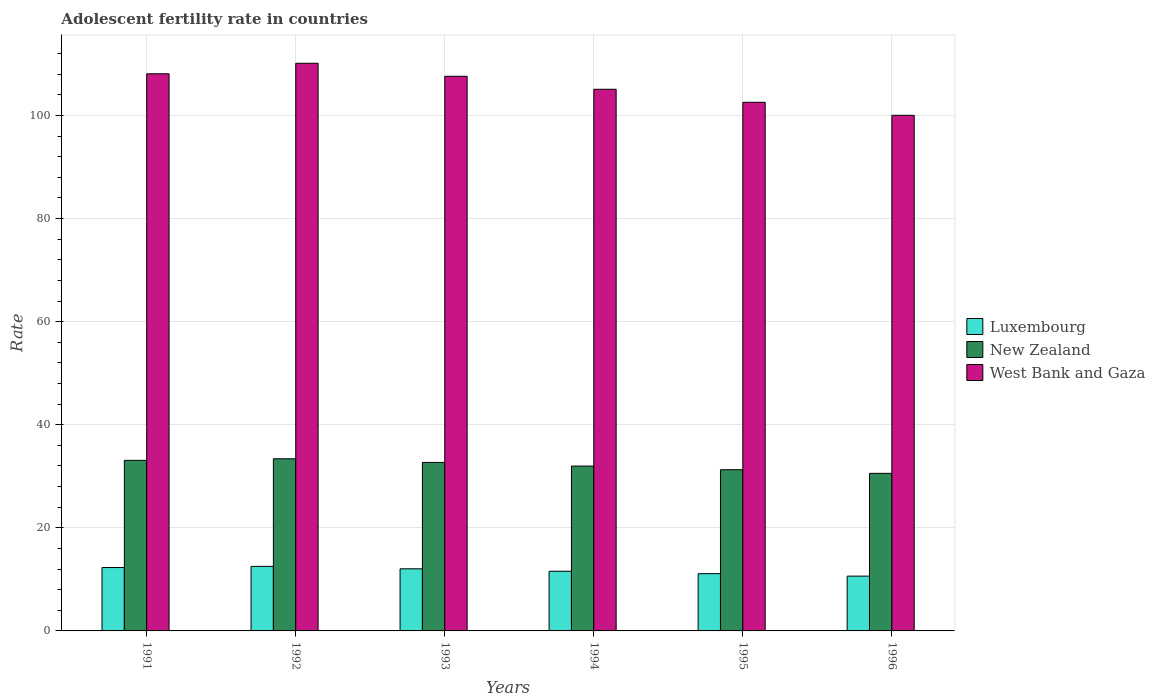How many different coloured bars are there?
Provide a short and direct response. 3. How many bars are there on the 6th tick from the left?
Keep it short and to the point. 3. What is the label of the 3rd group of bars from the left?
Offer a terse response. 1993. In how many cases, is the number of bars for a given year not equal to the number of legend labels?
Keep it short and to the point. 0. What is the adolescent fertility rate in New Zealand in 1991?
Keep it short and to the point. 33.09. Across all years, what is the maximum adolescent fertility rate in New Zealand?
Ensure brevity in your answer.  33.4. Across all years, what is the minimum adolescent fertility rate in New Zealand?
Offer a terse response. 30.57. In which year was the adolescent fertility rate in West Bank and Gaza maximum?
Your response must be concise. 1992. In which year was the adolescent fertility rate in New Zealand minimum?
Make the answer very short. 1996. What is the total adolescent fertility rate in Luxembourg in the graph?
Your answer should be compact. 70.18. What is the difference between the adolescent fertility rate in Luxembourg in 1992 and that in 1993?
Your answer should be very brief. 0.47. What is the difference between the adolescent fertility rate in West Bank and Gaza in 1992 and the adolescent fertility rate in Luxembourg in 1994?
Keep it short and to the point. 98.55. What is the average adolescent fertility rate in New Zealand per year?
Provide a succinct answer. 32.17. In the year 1992, what is the difference between the adolescent fertility rate in Luxembourg and adolescent fertility rate in New Zealand?
Your answer should be compact. -20.88. In how many years, is the adolescent fertility rate in West Bank and Gaza greater than 48?
Provide a short and direct response. 6. What is the ratio of the adolescent fertility rate in West Bank and Gaza in 1991 to that in 1993?
Offer a terse response. 1. Is the adolescent fertility rate in New Zealand in 1992 less than that in 1993?
Give a very brief answer. No. What is the difference between the highest and the second highest adolescent fertility rate in New Zealand?
Your answer should be very brief. 0.31. What is the difference between the highest and the lowest adolescent fertility rate in West Bank and Gaza?
Your answer should be very brief. 10.1. What does the 2nd bar from the left in 1993 represents?
Give a very brief answer. New Zealand. What does the 1st bar from the right in 1994 represents?
Offer a very short reply. West Bank and Gaza. Is it the case that in every year, the sum of the adolescent fertility rate in West Bank and Gaza and adolescent fertility rate in Luxembourg is greater than the adolescent fertility rate in New Zealand?
Offer a very short reply. Yes. How many bars are there?
Make the answer very short. 18. Are all the bars in the graph horizontal?
Keep it short and to the point. No. How many years are there in the graph?
Provide a succinct answer. 6. What is the difference between two consecutive major ticks on the Y-axis?
Provide a succinct answer. 20. Are the values on the major ticks of Y-axis written in scientific E-notation?
Provide a succinct answer. No. Where does the legend appear in the graph?
Ensure brevity in your answer.  Center right. What is the title of the graph?
Offer a terse response. Adolescent fertility rate in countries. Does "Congo (Republic)" appear as one of the legend labels in the graph?
Your answer should be compact. No. What is the label or title of the X-axis?
Offer a very short reply. Years. What is the label or title of the Y-axis?
Provide a short and direct response. Rate. What is the Rate in Luxembourg in 1991?
Your answer should be compact. 12.3. What is the Rate in New Zealand in 1991?
Give a very brief answer. 33.09. What is the Rate of West Bank and Gaza in 1991?
Your answer should be compact. 108.08. What is the Rate of Luxembourg in 1992?
Offer a very short reply. 12.52. What is the Rate of New Zealand in 1992?
Give a very brief answer. 33.4. What is the Rate of West Bank and Gaza in 1992?
Provide a succinct answer. 110.13. What is the Rate of Luxembourg in 1993?
Keep it short and to the point. 12.05. What is the Rate in New Zealand in 1993?
Your answer should be very brief. 32.69. What is the Rate of West Bank and Gaza in 1993?
Your answer should be very brief. 107.6. What is the Rate in Luxembourg in 1994?
Provide a short and direct response. 11.58. What is the Rate in New Zealand in 1994?
Offer a terse response. 31.98. What is the Rate of West Bank and Gaza in 1994?
Your response must be concise. 105.08. What is the Rate of Luxembourg in 1995?
Provide a short and direct response. 11.1. What is the Rate in New Zealand in 1995?
Ensure brevity in your answer.  31.28. What is the Rate of West Bank and Gaza in 1995?
Offer a terse response. 102.55. What is the Rate of Luxembourg in 1996?
Make the answer very short. 10.63. What is the Rate in New Zealand in 1996?
Make the answer very short. 30.57. What is the Rate in West Bank and Gaza in 1996?
Give a very brief answer. 100.03. Across all years, what is the maximum Rate in Luxembourg?
Your response must be concise. 12.52. Across all years, what is the maximum Rate of New Zealand?
Provide a short and direct response. 33.4. Across all years, what is the maximum Rate of West Bank and Gaza?
Your answer should be compact. 110.13. Across all years, what is the minimum Rate of Luxembourg?
Provide a short and direct response. 10.63. Across all years, what is the minimum Rate of New Zealand?
Provide a succinct answer. 30.57. Across all years, what is the minimum Rate in West Bank and Gaza?
Your answer should be compact. 100.03. What is the total Rate in Luxembourg in the graph?
Offer a terse response. 70.18. What is the total Rate in New Zealand in the graph?
Keep it short and to the point. 193.01. What is the total Rate in West Bank and Gaza in the graph?
Give a very brief answer. 633.48. What is the difference between the Rate in Luxembourg in 1991 and that in 1992?
Provide a succinct answer. -0.22. What is the difference between the Rate of New Zealand in 1991 and that in 1992?
Keep it short and to the point. -0.31. What is the difference between the Rate of West Bank and Gaza in 1991 and that in 1992?
Ensure brevity in your answer.  -2.04. What is the difference between the Rate in Luxembourg in 1991 and that in 1993?
Keep it short and to the point. 0.25. What is the difference between the Rate in New Zealand in 1991 and that in 1993?
Your answer should be very brief. 0.4. What is the difference between the Rate of West Bank and Gaza in 1991 and that in 1993?
Provide a succinct answer. 0.48. What is the difference between the Rate of Luxembourg in 1991 and that in 1994?
Keep it short and to the point. 0.72. What is the difference between the Rate in New Zealand in 1991 and that in 1994?
Your answer should be very brief. 1.11. What is the difference between the Rate of West Bank and Gaza in 1991 and that in 1994?
Offer a very short reply. 3. What is the difference between the Rate of Luxembourg in 1991 and that in 1995?
Ensure brevity in your answer.  1.19. What is the difference between the Rate in New Zealand in 1991 and that in 1995?
Make the answer very short. 1.81. What is the difference between the Rate in West Bank and Gaza in 1991 and that in 1995?
Provide a succinct answer. 5.53. What is the difference between the Rate in Luxembourg in 1991 and that in 1996?
Provide a succinct answer. 1.67. What is the difference between the Rate in New Zealand in 1991 and that in 1996?
Keep it short and to the point. 2.52. What is the difference between the Rate in West Bank and Gaza in 1991 and that in 1996?
Ensure brevity in your answer.  8.05. What is the difference between the Rate of Luxembourg in 1992 and that in 1993?
Provide a succinct answer. 0.47. What is the difference between the Rate of New Zealand in 1992 and that in 1993?
Provide a succinct answer. 0.71. What is the difference between the Rate of West Bank and Gaza in 1992 and that in 1993?
Offer a terse response. 2.52. What is the difference between the Rate in Luxembourg in 1992 and that in 1994?
Offer a terse response. 0.95. What is the difference between the Rate of New Zealand in 1992 and that in 1994?
Offer a very short reply. 1.41. What is the difference between the Rate of West Bank and Gaza in 1992 and that in 1994?
Your answer should be very brief. 5.05. What is the difference between the Rate of Luxembourg in 1992 and that in 1995?
Provide a short and direct response. 1.42. What is the difference between the Rate in New Zealand in 1992 and that in 1995?
Offer a very short reply. 2.12. What is the difference between the Rate in West Bank and Gaza in 1992 and that in 1995?
Your response must be concise. 7.57. What is the difference between the Rate of Luxembourg in 1992 and that in 1996?
Give a very brief answer. 1.89. What is the difference between the Rate in New Zealand in 1992 and that in 1996?
Provide a short and direct response. 2.83. What is the difference between the Rate of West Bank and Gaza in 1992 and that in 1996?
Your response must be concise. 10.1. What is the difference between the Rate in Luxembourg in 1993 and that in 1994?
Keep it short and to the point. 0.47. What is the difference between the Rate of New Zealand in 1993 and that in 1994?
Make the answer very short. 0.71. What is the difference between the Rate of West Bank and Gaza in 1993 and that in 1994?
Provide a short and direct response. 2.52. What is the difference between the Rate in Luxembourg in 1993 and that in 1995?
Provide a succinct answer. 0.95. What is the difference between the Rate of New Zealand in 1993 and that in 1995?
Your answer should be compact. 1.41. What is the difference between the Rate in West Bank and Gaza in 1993 and that in 1995?
Make the answer very short. 5.05. What is the difference between the Rate in Luxembourg in 1993 and that in 1996?
Your response must be concise. 1.42. What is the difference between the Rate in New Zealand in 1993 and that in 1996?
Provide a succinct answer. 2.12. What is the difference between the Rate in West Bank and Gaza in 1993 and that in 1996?
Provide a succinct answer. 7.57. What is the difference between the Rate of Luxembourg in 1994 and that in 1995?
Offer a terse response. 0.47. What is the difference between the Rate in New Zealand in 1994 and that in 1995?
Your answer should be compact. 0.71. What is the difference between the Rate in West Bank and Gaza in 1994 and that in 1995?
Provide a succinct answer. 2.52. What is the difference between the Rate of Luxembourg in 1994 and that in 1996?
Provide a succinct answer. 0.95. What is the difference between the Rate of New Zealand in 1994 and that in 1996?
Give a very brief answer. 1.41. What is the difference between the Rate of West Bank and Gaza in 1994 and that in 1996?
Your response must be concise. 5.05. What is the difference between the Rate of Luxembourg in 1995 and that in 1996?
Offer a terse response. 0.47. What is the difference between the Rate in New Zealand in 1995 and that in 1996?
Keep it short and to the point. 0.71. What is the difference between the Rate in West Bank and Gaza in 1995 and that in 1996?
Your answer should be very brief. 2.52. What is the difference between the Rate in Luxembourg in 1991 and the Rate in New Zealand in 1992?
Your answer should be compact. -21.1. What is the difference between the Rate in Luxembourg in 1991 and the Rate in West Bank and Gaza in 1992?
Ensure brevity in your answer.  -97.83. What is the difference between the Rate of New Zealand in 1991 and the Rate of West Bank and Gaza in 1992?
Your response must be concise. -77.04. What is the difference between the Rate in Luxembourg in 1991 and the Rate in New Zealand in 1993?
Your response must be concise. -20.39. What is the difference between the Rate in Luxembourg in 1991 and the Rate in West Bank and Gaza in 1993?
Provide a short and direct response. -95.31. What is the difference between the Rate of New Zealand in 1991 and the Rate of West Bank and Gaza in 1993?
Provide a short and direct response. -74.51. What is the difference between the Rate in Luxembourg in 1991 and the Rate in New Zealand in 1994?
Keep it short and to the point. -19.69. What is the difference between the Rate in Luxembourg in 1991 and the Rate in West Bank and Gaza in 1994?
Offer a terse response. -92.78. What is the difference between the Rate in New Zealand in 1991 and the Rate in West Bank and Gaza in 1994?
Ensure brevity in your answer.  -71.99. What is the difference between the Rate in Luxembourg in 1991 and the Rate in New Zealand in 1995?
Provide a succinct answer. -18.98. What is the difference between the Rate in Luxembourg in 1991 and the Rate in West Bank and Gaza in 1995?
Ensure brevity in your answer.  -90.26. What is the difference between the Rate of New Zealand in 1991 and the Rate of West Bank and Gaza in 1995?
Provide a short and direct response. -69.46. What is the difference between the Rate in Luxembourg in 1991 and the Rate in New Zealand in 1996?
Provide a succinct answer. -18.27. What is the difference between the Rate in Luxembourg in 1991 and the Rate in West Bank and Gaza in 1996?
Offer a terse response. -87.73. What is the difference between the Rate of New Zealand in 1991 and the Rate of West Bank and Gaza in 1996?
Your answer should be very brief. -66.94. What is the difference between the Rate of Luxembourg in 1992 and the Rate of New Zealand in 1993?
Keep it short and to the point. -20.17. What is the difference between the Rate in Luxembourg in 1992 and the Rate in West Bank and Gaza in 1993?
Offer a very short reply. -95.08. What is the difference between the Rate of New Zealand in 1992 and the Rate of West Bank and Gaza in 1993?
Keep it short and to the point. -74.2. What is the difference between the Rate in Luxembourg in 1992 and the Rate in New Zealand in 1994?
Give a very brief answer. -19.46. What is the difference between the Rate in Luxembourg in 1992 and the Rate in West Bank and Gaza in 1994?
Provide a short and direct response. -92.56. What is the difference between the Rate in New Zealand in 1992 and the Rate in West Bank and Gaza in 1994?
Your answer should be very brief. -71.68. What is the difference between the Rate in Luxembourg in 1992 and the Rate in New Zealand in 1995?
Your response must be concise. -18.75. What is the difference between the Rate of Luxembourg in 1992 and the Rate of West Bank and Gaza in 1995?
Make the answer very short. -90.03. What is the difference between the Rate of New Zealand in 1992 and the Rate of West Bank and Gaza in 1995?
Ensure brevity in your answer.  -69.16. What is the difference between the Rate of Luxembourg in 1992 and the Rate of New Zealand in 1996?
Offer a very short reply. -18.05. What is the difference between the Rate in Luxembourg in 1992 and the Rate in West Bank and Gaza in 1996?
Offer a very short reply. -87.51. What is the difference between the Rate of New Zealand in 1992 and the Rate of West Bank and Gaza in 1996?
Offer a very short reply. -66.63. What is the difference between the Rate in Luxembourg in 1993 and the Rate in New Zealand in 1994?
Provide a short and direct response. -19.93. What is the difference between the Rate of Luxembourg in 1993 and the Rate of West Bank and Gaza in 1994?
Give a very brief answer. -93.03. What is the difference between the Rate in New Zealand in 1993 and the Rate in West Bank and Gaza in 1994?
Give a very brief answer. -72.39. What is the difference between the Rate in Luxembourg in 1993 and the Rate in New Zealand in 1995?
Keep it short and to the point. -19.23. What is the difference between the Rate of Luxembourg in 1993 and the Rate of West Bank and Gaza in 1995?
Ensure brevity in your answer.  -90.5. What is the difference between the Rate of New Zealand in 1993 and the Rate of West Bank and Gaza in 1995?
Your response must be concise. -69.86. What is the difference between the Rate of Luxembourg in 1993 and the Rate of New Zealand in 1996?
Ensure brevity in your answer.  -18.52. What is the difference between the Rate in Luxembourg in 1993 and the Rate in West Bank and Gaza in 1996?
Provide a short and direct response. -87.98. What is the difference between the Rate of New Zealand in 1993 and the Rate of West Bank and Gaza in 1996?
Keep it short and to the point. -67.34. What is the difference between the Rate of Luxembourg in 1994 and the Rate of New Zealand in 1995?
Keep it short and to the point. -19.7. What is the difference between the Rate of Luxembourg in 1994 and the Rate of West Bank and Gaza in 1995?
Offer a very short reply. -90.98. What is the difference between the Rate in New Zealand in 1994 and the Rate in West Bank and Gaza in 1995?
Your answer should be very brief. -70.57. What is the difference between the Rate in Luxembourg in 1994 and the Rate in New Zealand in 1996?
Ensure brevity in your answer.  -18.99. What is the difference between the Rate in Luxembourg in 1994 and the Rate in West Bank and Gaza in 1996?
Your answer should be very brief. -88.45. What is the difference between the Rate in New Zealand in 1994 and the Rate in West Bank and Gaza in 1996?
Your answer should be very brief. -68.05. What is the difference between the Rate of Luxembourg in 1995 and the Rate of New Zealand in 1996?
Provide a short and direct response. -19.46. What is the difference between the Rate in Luxembourg in 1995 and the Rate in West Bank and Gaza in 1996?
Offer a terse response. -88.93. What is the difference between the Rate in New Zealand in 1995 and the Rate in West Bank and Gaza in 1996?
Your response must be concise. -68.75. What is the average Rate in Luxembourg per year?
Give a very brief answer. 11.7. What is the average Rate of New Zealand per year?
Your answer should be compact. 32.17. What is the average Rate in West Bank and Gaza per year?
Offer a very short reply. 105.58. In the year 1991, what is the difference between the Rate of Luxembourg and Rate of New Zealand?
Your answer should be very brief. -20.79. In the year 1991, what is the difference between the Rate in Luxembourg and Rate in West Bank and Gaza?
Your answer should be compact. -95.79. In the year 1991, what is the difference between the Rate of New Zealand and Rate of West Bank and Gaza?
Provide a succinct answer. -74.99. In the year 1992, what is the difference between the Rate of Luxembourg and Rate of New Zealand?
Make the answer very short. -20.88. In the year 1992, what is the difference between the Rate in Luxembourg and Rate in West Bank and Gaza?
Your answer should be compact. -97.61. In the year 1992, what is the difference between the Rate of New Zealand and Rate of West Bank and Gaza?
Ensure brevity in your answer.  -76.73. In the year 1993, what is the difference between the Rate of Luxembourg and Rate of New Zealand?
Your answer should be compact. -20.64. In the year 1993, what is the difference between the Rate in Luxembourg and Rate in West Bank and Gaza?
Your answer should be very brief. -95.55. In the year 1993, what is the difference between the Rate of New Zealand and Rate of West Bank and Gaza?
Provide a short and direct response. -74.91. In the year 1994, what is the difference between the Rate in Luxembourg and Rate in New Zealand?
Provide a short and direct response. -20.41. In the year 1994, what is the difference between the Rate in Luxembourg and Rate in West Bank and Gaza?
Offer a terse response. -93.5. In the year 1994, what is the difference between the Rate of New Zealand and Rate of West Bank and Gaza?
Offer a terse response. -73.09. In the year 1995, what is the difference between the Rate of Luxembourg and Rate of New Zealand?
Your answer should be very brief. -20.17. In the year 1995, what is the difference between the Rate in Luxembourg and Rate in West Bank and Gaza?
Your answer should be compact. -91.45. In the year 1995, what is the difference between the Rate of New Zealand and Rate of West Bank and Gaza?
Give a very brief answer. -71.28. In the year 1996, what is the difference between the Rate of Luxembourg and Rate of New Zealand?
Offer a terse response. -19.94. In the year 1996, what is the difference between the Rate in Luxembourg and Rate in West Bank and Gaza?
Your response must be concise. -89.4. In the year 1996, what is the difference between the Rate in New Zealand and Rate in West Bank and Gaza?
Make the answer very short. -69.46. What is the ratio of the Rate of Luxembourg in 1991 to that in 1992?
Give a very brief answer. 0.98. What is the ratio of the Rate of West Bank and Gaza in 1991 to that in 1992?
Give a very brief answer. 0.98. What is the ratio of the Rate in Luxembourg in 1991 to that in 1993?
Ensure brevity in your answer.  1.02. What is the ratio of the Rate of New Zealand in 1991 to that in 1993?
Your answer should be compact. 1.01. What is the ratio of the Rate in Luxembourg in 1991 to that in 1994?
Ensure brevity in your answer.  1.06. What is the ratio of the Rate in New Zealand in 1991 to that in 1994?
Ensure brevity in your answer.  1.03. What is the ratio of the Rate of West Bank and Gaza in 1991 to that in 1994?
Offer a terse response. 1.03. What is the ratio of the Rate in Luxembourg in 1991 to that in 1995?
Offer a terse response. 1.11. What is the ratio of the Rate of New Zealand in 1991 to that in 1995?
Offer a very short reply. 1.06. What is the ratio of the Rate in West Bank and Gaza in 1991 to that in 1995?
Provide a short and direct response. 1.05. What is the ratio of the Rate in Luxembourg in 1991 to that in 1996?
Ensure brevity in your answer.  1.16. What is the ratio of the Rate of New Zealand in 1991 to that in 1996?
Provide a short and direct response. 1.08. What is the ratio of the Rate in West Bank and Gaza in 1991 to that in 1996?
Provide a succinct answer. 1.08. What is the ratio of the Rate of Luxembourg in 1992 to that in 1993?
Your answer should be compact. 1.04. What is the ratio of the Rate in New Zealand in 1992 to that in 1993?
Provide a succinct answer. 1.02. What is the ratio of the Rate in West Bank and Gaza in 1992 to that in 1993?
Provide a succinct answer. 1.02. What is the ratio of the Rate in Luxembourg in 1992 to that in 1994?
Offer a very short reply. 1.08. What is the ratio of the Rate of New Zealand in 1992 to that in 1994?
Give a very brief answer. 1.04. What is the ratio of the Rate in West Bank and Gaza in 1992 to that in 1994?
Offer a very short reply. 1.05. What is the ratio of the Rate in Luxembourg in 1992 to that in 1995?
Your response must be concise. 1.13. What is the ratio of the Rate in New Zealand in 1992 to that in 1995?
Offer a terse response. 1.07. What is the ratio of the Rate of West Bank and Gaza in 1992 to that in 1995?
Give a very brief answer. 1.07. What is the ratio of the Rate of Luxembourg in 1992 to that in 1996?
Make the answer very short. 1.18. What is the ratio of the Rate in New Zealand in 1992 to that in 1996?
Your answer should be compact. 1.09. What is the ratio of the Rate of West Bank and Gaza in 1992 to that in 1996?
Your response must be concise. 1.1. What is the ratio of the Rate in Luxembourg in 1993 to that in 1994?
Ensure brevity in your answer.  1.04. What is the ratio of the Rate of New Zealand in 1993 to that in 1994?
Give a very brief answer. 1.02. What is the ratio of the Rate in West Bank and Gaza in 1993 to that in 1994?
Ensure brevity in your answer.  1.02. What is the ratio of the Rate in Luxembourg in 1993 to that in 1995?
Offer a very short reply. 1.09. What is the ratio of the Rate in New Zealand in 1993 to that in 1995?
Offer a very short reply. 1.05. What is the ratio of the Rate in West Bank and Gaza in 1993 to that in 1995?
Offer a terse response. 1.05. What is the ratio of the Rate in Luxembourg in 1993 to that in 1996?
Give a very brief answer. 1.13. What is the ratio of the Rate in New Zealand in 1993 to that in 1996?
Provide a short and direct response. 1.07. What is the ratio of the Rate of West Bank and Gaza in 1993 to that in 1996?
Your response must be concise. 1.08. What is the ratio of the Rate in Luxembourg in 1994 to that in 1995?
Provide a succinct answer. 1.04. What is the ratio of the Rate of New Zealand in 1994 to that in 1995?
Ensure brevity in your answer.  1.02. What is the ratio of the Rate of West Bank and Gaza in 1994 to that in 1995?
Make the answer very short. 1.02. What is the ratio of the Rate in Luxembourg in 1994 to that in 1996?
Your answer should be very brief. 1.09. What is the ratio of the Rate in New Zealand in 1994 to that in 1996?
Keep it short and to the point. 1.05. What is the ratio of the Rate of West Bank and Gaza in 1994 to that in 1996?
Ensure brevity in your answer.  1.05. What is the ratio of the Rate of Luxembourg in 1995 to that in 1996?
Give a very brief answer. 1.04. What is the ratio of the Rate in New Zealand in 1995 to that in 1996?
Offer a terse response. 1.02. What is the ratio of the Rate in West Bank and Gaza in 1995 to that in 1996?
Provide a short and direct response. 1.03. What is the difference between the highest and the second highest Rate in Luxembourg?
Your answer should be very brief. 0.22. What is the difference between the highest and the second highest Rate of New Zealand?
Provide a succinct answer. 0.31. What is the difference between the highest and the second highest Rate in West Bank and Gaza?
Offer a very short reply. 2.04. What is the difference between the highest and the lowest Rate of Luxembourg?
Make the answer very short. 1.89. What is the difference between the highest and the lowest Rate of New Zealand?
Keep it short and to the point. 2.83. What is the difference between the highest and the lowest Rate in West Bank and Gaza?
Offer a very short reply. 10.1. 